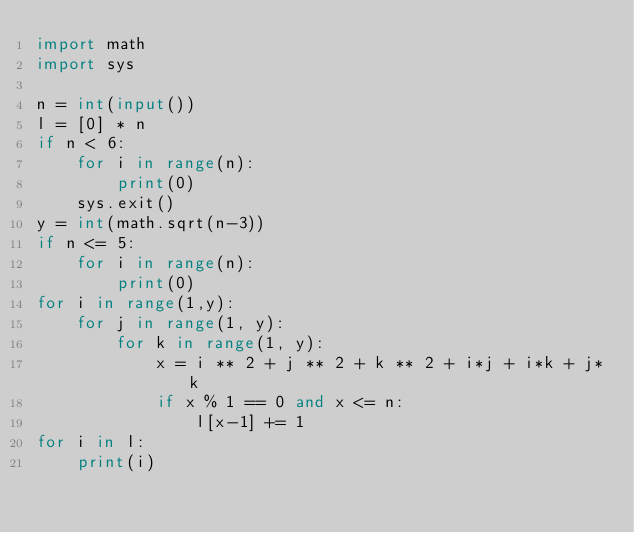Convert code to text. <code><loc_0><loc_0><loc_500><loc_500><_Python_>import math
import sys

n = int(input())
l = [0] * n
if n < 6:
    for i in range(n):
        print(0)
    sys.exit()
y = int(math.sqrt(n-3))
if n <= 5:
    for i in range(n):
        print(0)
for i in range(1,y):
    for j in range(1, y):
        for k in range(1, y):
            x = i ** 2 + j ** 2 + k ** 2 + i*j + i*k + j*k
            if x % 1 == 0 and x <= n:
                l[x-1] += 1
for i in l:
    print(i)</code> 